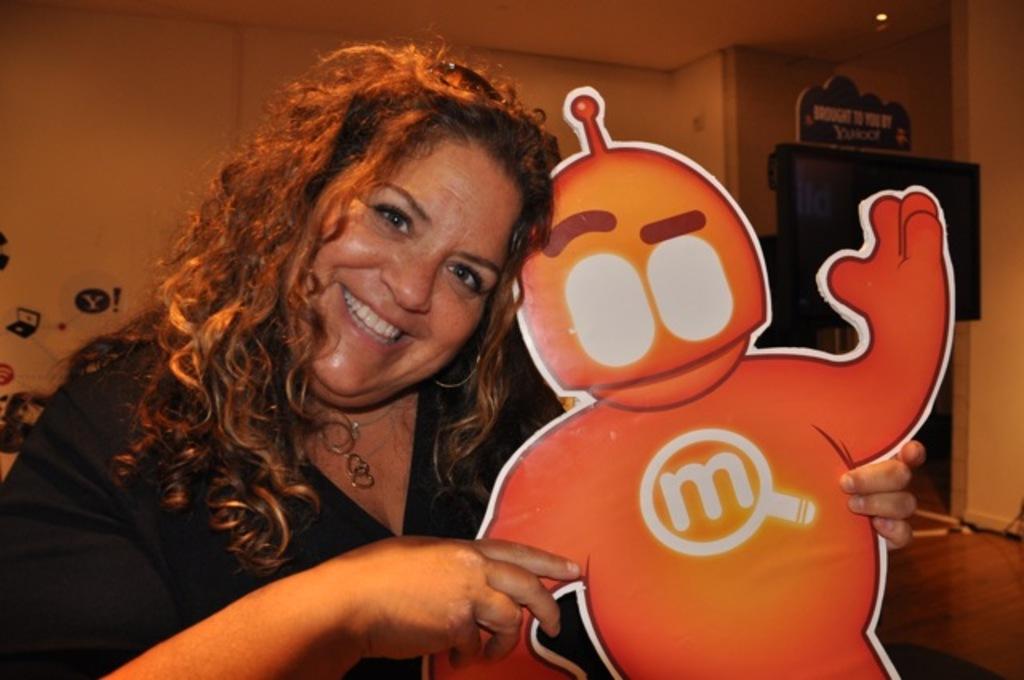What search engine is advertised in the back?
Give a very brief answer. Yahoo. 